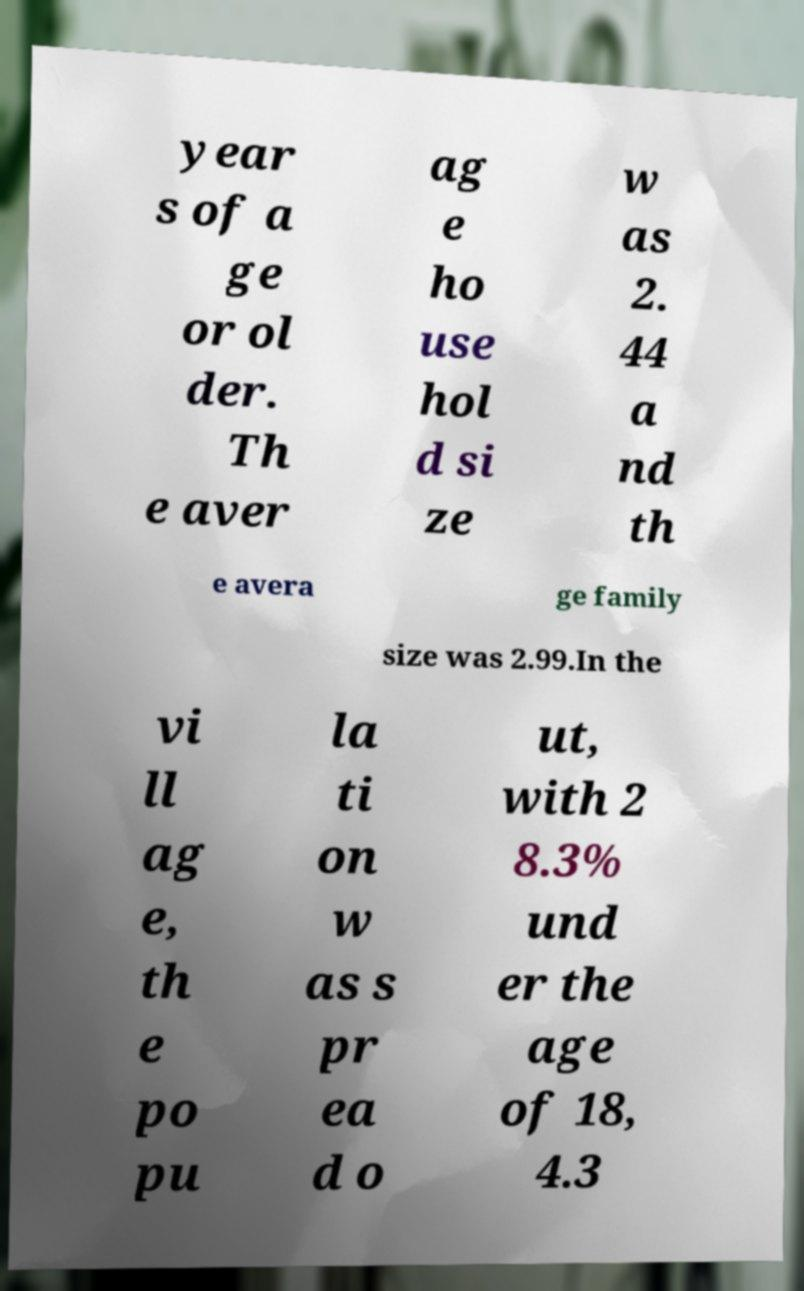Please read and relay the text visible in this image. What does it say? year s of a ge or ol der. Th e aver ag e ho use hol d si ze w as 2. 44 a nd th e avera ge family size was 2.99.In the vi ll ag e, th e po pu la ti on w as s pr ea d o ut, with 2 8.3% und er the age of 18, 4.3 